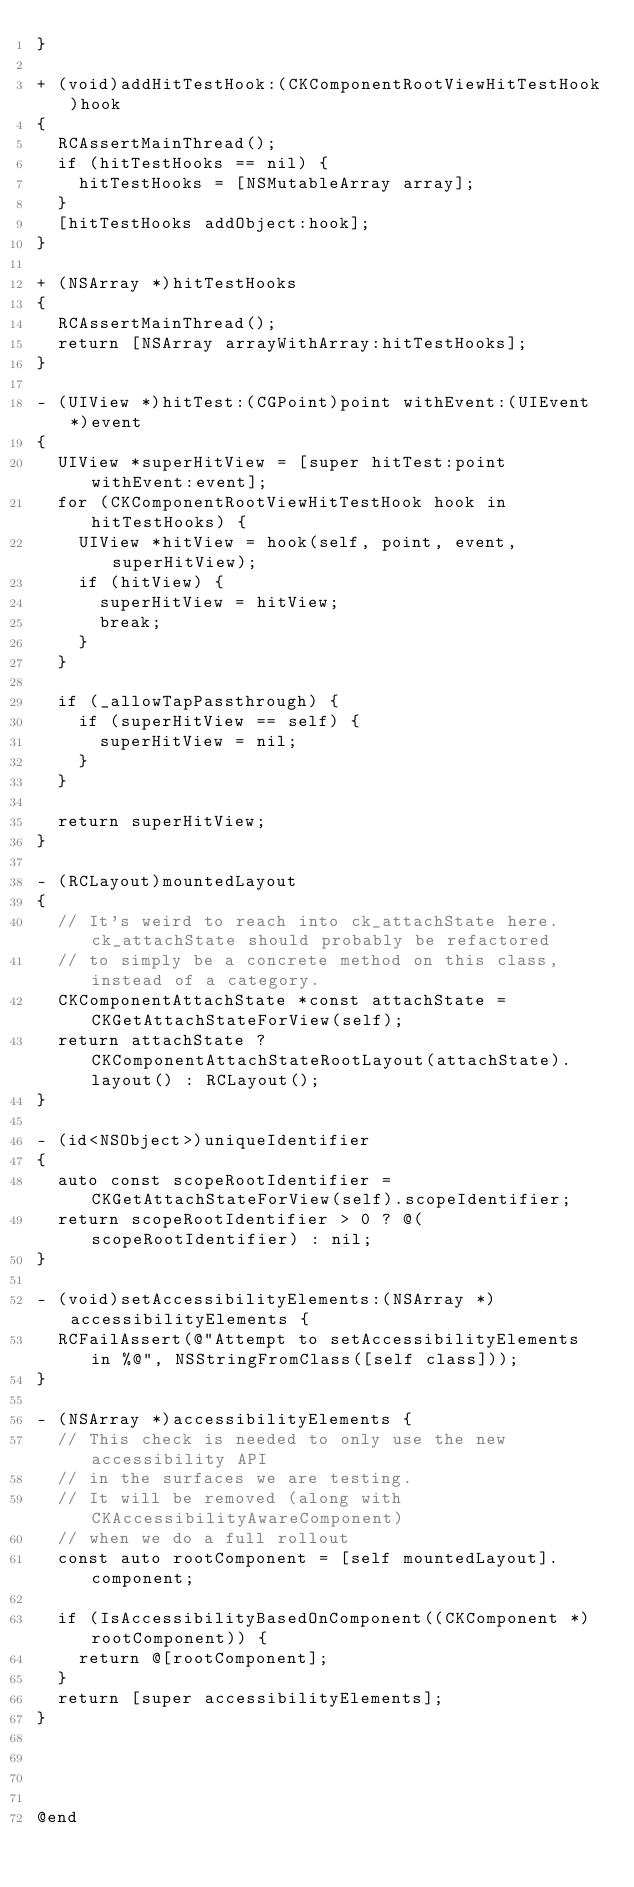Convert code to text. <code><loc_0><loc_0><loc_500><loc_500><_ObjectiveC_>}

+ (void)addHitTestHook:(CKComponentRootViewHitTestHook)hook
{
  RCAssertMainThread();
  if (hitTestHooks == nil) {
    hitTestHooks = [NSMutableArray array];
  }
  [hitTestHooks addObject:hook];
}

+ (NSArray *)hitTestHooks
{
  RCAssertMainThread();
  return [NSArray arrayWithArray:hitTestHooks];
}

- (UIView *)hitTest:(CGPoint)point withEvent:(UIEvent *)event
{
  UIView *superHitView = [super hitTest:point withEvent:event];
  for (CKComponentRootViewHitTestHook hook in hitTestHooks) {
    UIView *hitView = hook(self, point, event, superHitView);
    if (hitView) {
      superHitView = hitView;
      break;
    }
  }

  if (_allowTapPassthrough) {
    if (superHitView == self) {
      superHitView = nil;
    }
  }

  return superHitView;
}

- (RCLayout)mountedLayout
{
  // It's weird to reach into ck_attachState here. ck_attachState should probably be refactored
  // to simply be a concrete method on this class, instead of a category.
  CKComponentAttachState *const attachState = CKGetAttachStateForView(self);
  return attachState ? CKComponentAttachStateRootLayout(attachState).layout() : RCLayout();
}

- (id<NSObject>)uniqueIdentifier
{
  auto const scopeRootIdentifier = CKGetAttachStateForView(self).scopeIdentifier;
  return scopeRootIdentifier > 0 ? @(scopeRootIdentifier) : nil;
}

- (void)setAccessibilityElements:(NSArray *)accessibilityElements {
  RCFailAssert(@"Attempt to setAccessibilityElements in %@", NSStringFromClass([self class]));
}

- (NSArray *)accessibilityElements {
  // This check is needed to only use the new accessibility API
  // in the surfaces we are testing.
  // It will be removed (along with CKAccessibilityAwareComponent)
  // when we do a full rollout
  const auto rootComponent = [self mountedLayout].component;

  if (IsAccessibilityBasedOnComponent((CKComponent *)rootComponent)) {
    return @[rootComponent];
  }
  return [super accessibilityElements];
}




@end
</code> 